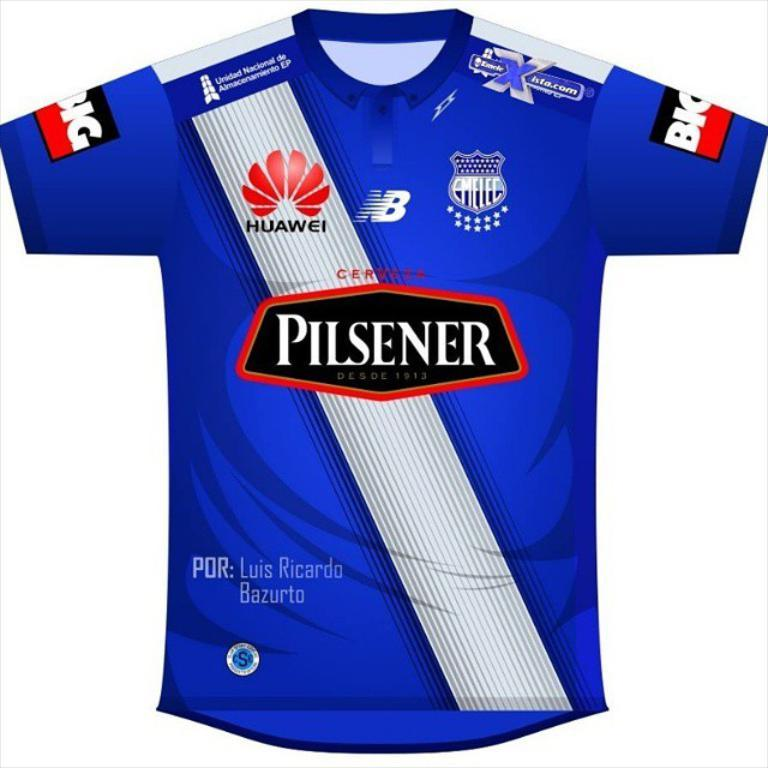Provide a one-sentence caption for the provided image. Blue soccer jersey which says Pilsener on the front. 